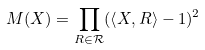Convert formula to latex. <formula><loc_0><loc_0><loc_500><loc_500>M ( X ) = \prod _ { R \in \mathcal { R } } ( \left \langle X , R \right \rangle - 1 ) ^ { 2 }</formula> 